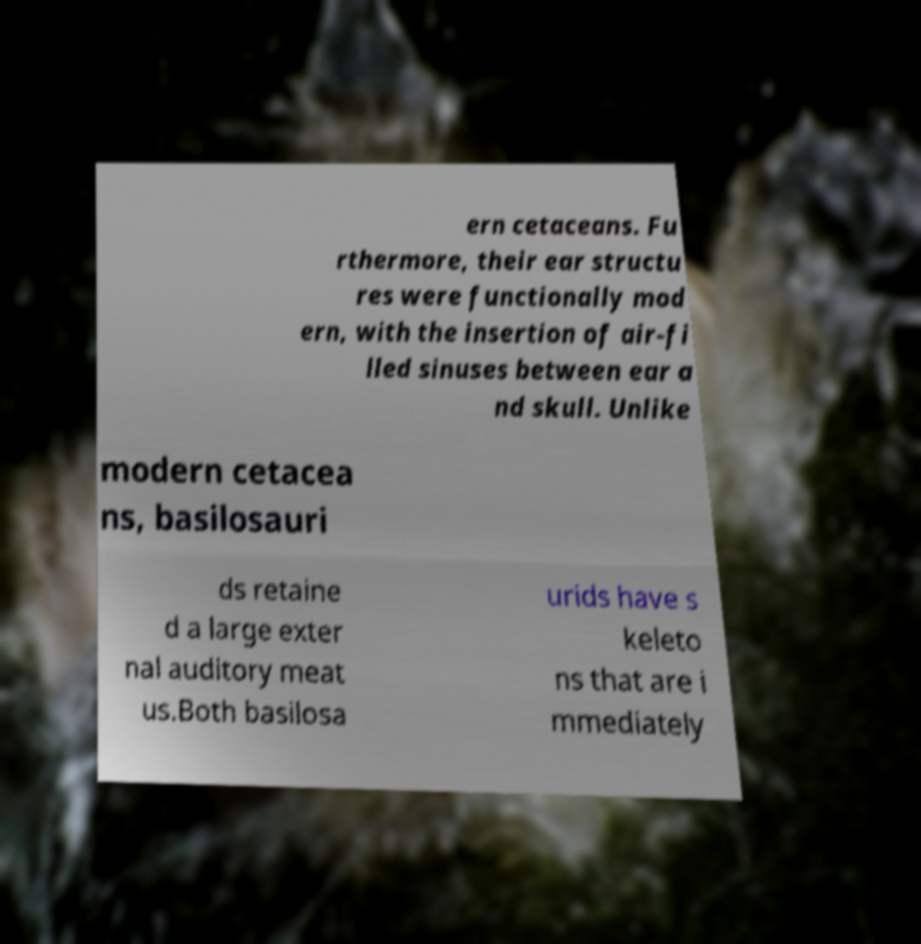I need the written content from this picture converted into text. Can you do that? ern cetaceans. Fu rthermore, their ear structu res were functionally mod ern, with the insertion of air-fi lled sinuses between ear a nd skull. Unlike modern cetacea ns, basilosauri ds retaine d a large exter nal auditory meat us.Both basilosa urids have s keleto ns that are i mmediately 